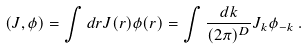Convert formula to latex. <formula><loc_0><loc_0><loc_500><loc_500>( J , \phi ) = \int d { r } J ( { r } ) \phi ( { r } ) = \int \frac { d { k } } { ( 2 \pi ) ^ { D } } J _ { k } \phi _ { - { k } } \, .</formula> 